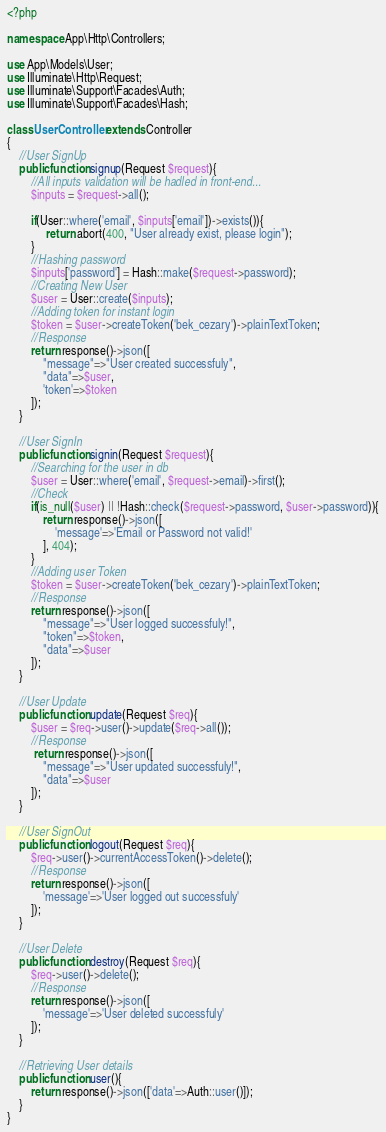Convert code to text. <code><loc_0><loc_0><loc_500><loc_500><_PHP_><?php

namespace App\Http\Controllers;

use App\Models\User;
use Illuminate\Http\Request;
use Illuminate\Support\Facades\Auth;
use Illuminate\Support\Facades\Hash;

class UserController extends Controller
{
    //User SignUp
    public function signup(Request $request){
        //All inputs validation will be hadled in front-end...
        $inputs = $request->all();

        if(User::where('email', $inputs['email'])->exists()){
             return abort(400, "User already exist, please login");
        }
        //Hashing password
        $inputs['password'] = Hash::make($request->password);
        //Creating New User
        $user = User::create($inputs);
        //Adding token for instant login
        $token = $user->createToken('bek_cezary')->plainTextToken;
        //Response
        return response()->json([
            "message"=>"User created successfuly",
            "data"=>$user,
            'token'=>$token
        ]);
    }

    //User SignIn
    public function signin(Request $request){
        //Searching for the user in db
        $user = User::where('email', $request->email)->first();
        //Check
        if(is_null($user) || !Hash::check($request->password, $user->password)){
            return response()->json([
                'message'=>'Email or Password not valid!'
            ], 404);
        }
        //Adding user Token
        $token = $user->createToken('bek_cezary')->plainTextToken;
        //Response
        return response()->json([
            "message"=>"User logged successfuly!",
            "token"=>$token,
            "data"=>$user
        ]);
    }

    //User Update
    public function update(Request $req){
        $user = $req->user()->update($req->all());
        //Response
         return response()->json([
            "message"=>"User updated successfuly!",
            "data"=>$user
        ]);
    }

    //User SignOut
    public function logout(Request $req){
        $req->user()->currentAccessToken()->delete();
        //Response
        return response()->json([
            'message'=>'User logged out successfuly'
        ]);
    }

    //User Delete
    public function destroy(Request $req){
        $req->user()->delete();
        //Response
        return response()->json([
            'message'=>'User deleted successfuly'
        ]);
    }

    //Retrieving User details
    public function user(){
        return response()->json(['data'=>Auth::user()]);
    }    
}
</code> 